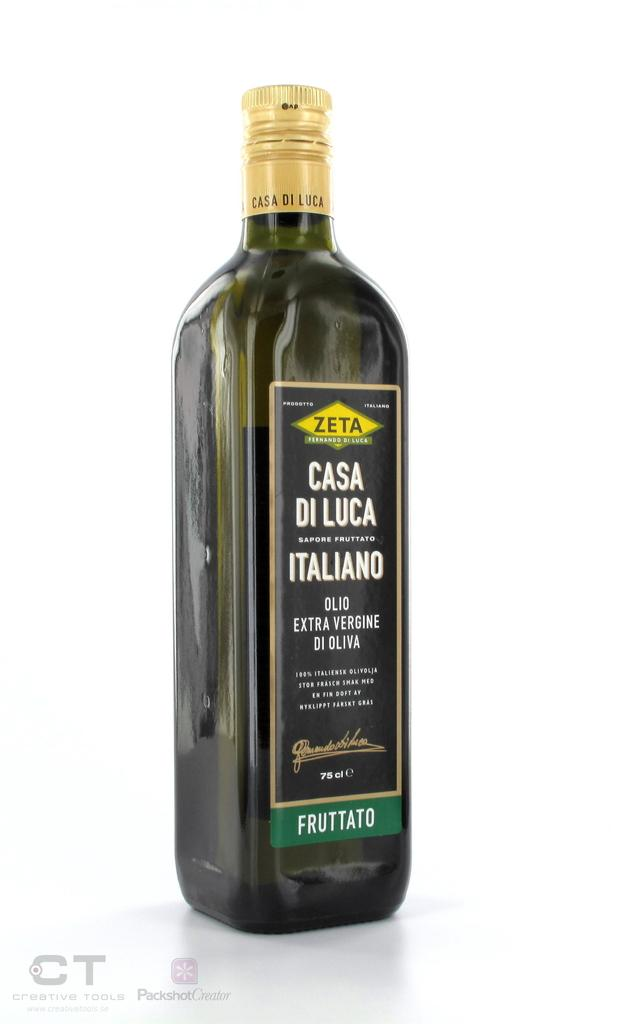<image>
Relay a brief, clear account of the picture shown. A bottle of Casa Di Luca Extra Vergine Di Oliva. 